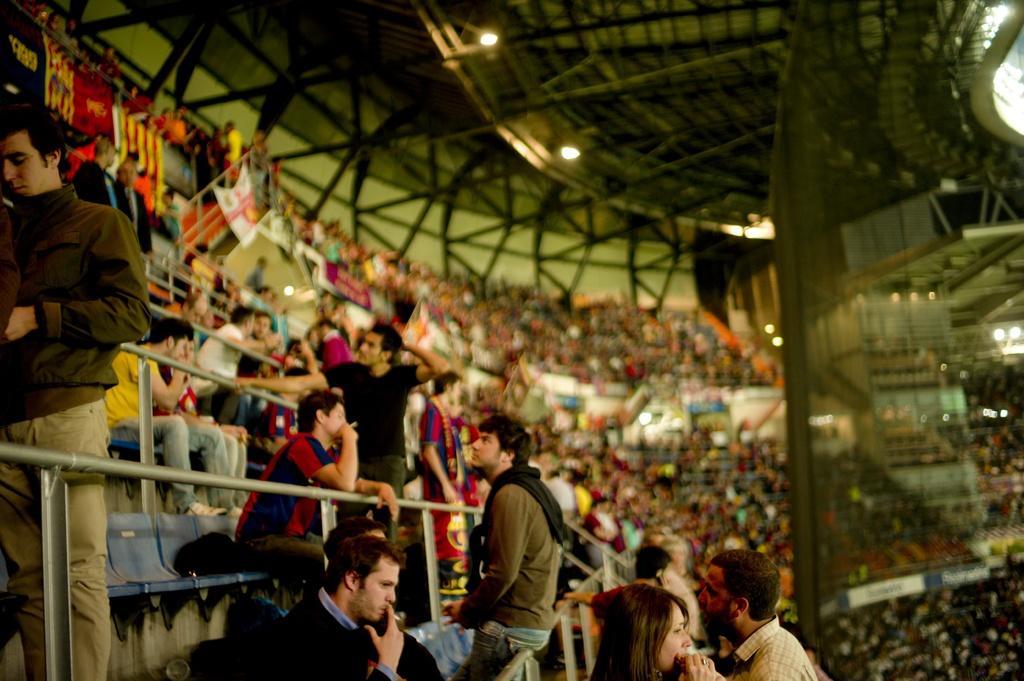Could you give a brief overview of what you see in this image? In this image, in the front, we can see people and some are holding cigarettes and we can see rods and chairs and there are flags. In the background, there is a crowd and we can see a cloth, lights and at the top, there is a roof. 